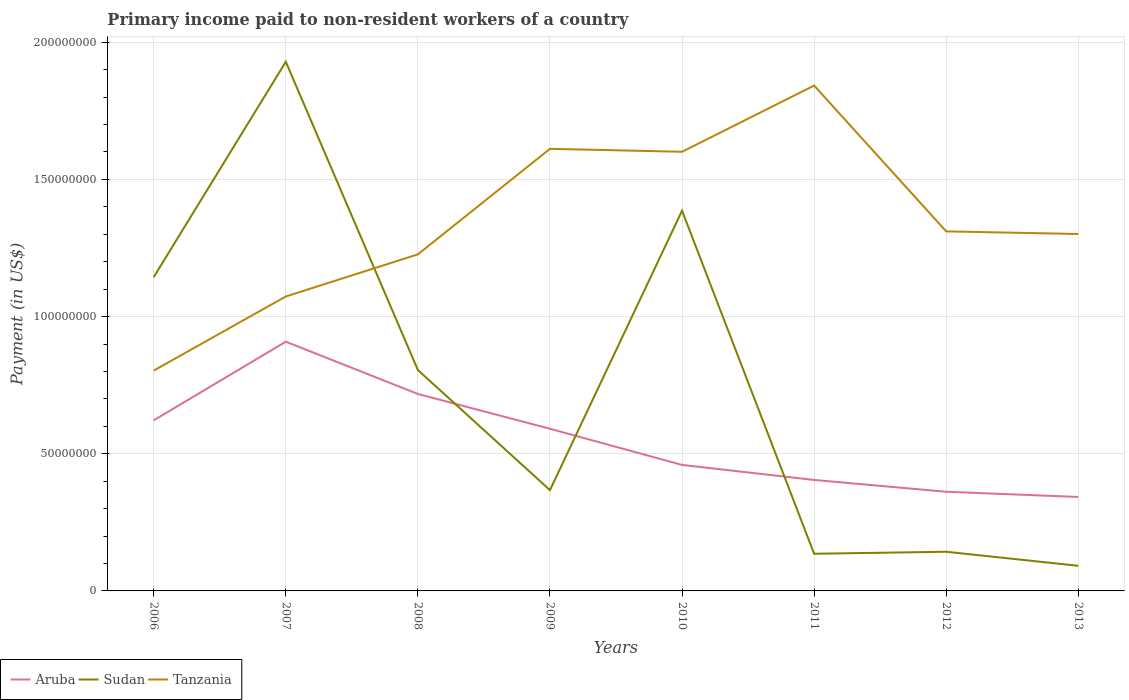How many different coloured lines are there?
Offer a terse response. 3. Is the number of lines equal to the number of legend labels?
Make the answer very short. Yes. Across all years, what is the maximum amount paid to workers in Sudan?
Your answer should be very brief. 9.16e+06. In which year was the amount paid to workers in Aruba maximum?
Ensure brevity in your answer.  2013. What is the total amount paid to workers in Aruba in the graph?
Your answer should be compact. 1.87e+07. What is the difference between the highest and the second highest amount paid to workers in Tanzania?
Provide a short and direct response. 1.04e+08. Does the graph contain any zero values?
Your response must be concise. No. Where does the legend appear in the graph?
Your answer should be compact. Bottom left. What is the title of the graph?
Your answer should be compact. Primary income paid to non-resident workers of a country. What is the label or title of the X-axis?
Make the answer very short. Years. What is the label or title of the Y-axis?
Provide a succinct answer. Payment (in US$). What is the Payment (in US$) in Aruba in 2006?
Provide a short and direct response. 6.22e+07. What is the Payment (in US$) of Sudan in 2006?
Provide a short and direct response. 1.14e+08. What is the Payment (in US$) in Tanzania in 2006?
Your answer should be very brief. 8.03e+07. What is the Payment (in US$) of Aruba in 2007?
Your response must be concise. 9.08e+07. What is the Payment (in US$) of Sudan in 2007?
Offer a very short reply. 1.93e+08. What is the Payment (in US$) of Tanzania in 2007?
Your answer should be compact. 1.07e+08. What is the Payment (in US$) in Aruba in 2008?
Ensure brevity in your answer.  7.18e+07. What is the Payment (in US$) of Sudan in 2008?
Your answer should be compact. 8.05e+07. What is the Payment (in US$) in Tanzania in 2008?
Make the answer very short. 1.23e+08. What is the Payment (in US$) in Aruba in 2009?
Give a very brief answer. 5.91e+07. What is the Payment (in US$) in Sudan in 2009?
Ensure brevity in your answer.  3.67e+07. What is the Payment (in US$) in Tanzania in 2009?
Your answer should be compact. 1.61e+08. What is the Payment (in US$) of Aruba in 2010?
Make the answer very short. 4.59e+07. What is the Payment (in US$) of Sudan in 2010?
Offer a terse response. 1.39e+08. What is the Payment (in US$) of Tanzania in 2010?
Make the answer very short. 1.60e+08. What is the Payment (in US$) of Aruba in 2011?
Provide a short and direct response. 4.04e+07. What is the Payment (in US$) of Sudan in 2011?
Make the answer very short. 1.35e+07. What is the Payment (in US$) of Tanzania in 2011?
Your answer should be compact. 1.84e+08. What is the Payment (in US$) in Aruba in 2012?
Offer a terse response. 3.61e+07. What is the Payment (in US$) of Sudan in 2012?
Your answer should be very brief. 1.43e+07. What is the Payment (in US$) in Tanzania in 2012?
Offer a terse response. 1.31e+08. What is the Payment (in US$) of Aruba in 2013?
Your answer should be compact. 3.42e+07. What is the Payment (in US$) in Sudan in 2013?
Your answer should be compact. 9.16e+06. What is the Payment (in US$) in Tanzania in 2013?
Ensure brevity in your answer.  1.30e+08. Across all years, what is the maximum Payment (in US$) in Aruba?
Provide a succinct answer. 9.08e+07. Across all years, what is the maximum Payment (in US$) of Sudan?
Provide a succinct answer. 1.93e+08. Across all years, what is the maximum Payment (in US$) in Tanzania?
Provide a succinct answer. 1.84e+08. Across all years, what is the minimum Payment (in US$) of Aruba?
Your answer should be very brief. 3.42e+07. Across all years, what is the minimum Payment (in US$) of Sudan?
Your answer should be very brief. 9.16e+06. Across all years, what is the minimum Payment (in US$) in Tanzania?
Your response must be concise. 8.03e+07. What is the total Payment (in US$) in Aruba in the graph?
Make the answer very short. 4.41e+08. What is the total Payment (in US$) of Sudan in the graph?
Offer a terse response. 6.00e+08. What is the total Payment (in US$) of Tanzania in the graph?
Offer a very short reply. 1.08e+09. What is the difference between the Payment (in US$) in Aruba in 2006 and that in 2007?
Keep it short and to the point. -2.87e+07. What is the difference between the Payment (in US$) in Sudan in 2006 and that in 2007?
Ensure brevity in your answer.  -7.85e+07. What is the difference between the Payment (in US$) in Tanzania in 2006 and that in 2007?
Offer a terse response. -2.70e+07. What is the difference between the Payment (in US$) of Aruba in 2006 and that in 2008?
Make the answer very short. -9.60e+06. What is the difference between the Payment (in US$) in Sudan in 2006 and that in 2008?
Your answer should be compact. 3.39e+07. What is the difference between the Payment (in US$) of Tanzania in 2006 and that in 2008?
Keep it short and to the point. -4.24e+07. What is the difference between the Payment (in US$) of Aruba in 2006 and that in 2009?
Provide a succinct answer. 3.08e+06. What is the difference between the Payment (in US$) in Sudan in 2006 and that in 2009?
Offer a very short reply. 7.76e+07. What is the difference between the Payment (in US$) in Tanzania in 2006 and that in 2009?
Provide a short and direct response. -8.08e+07. What is the difference between the Payment (in US$) in Aruba in 2006 and that in 2010?
Offer a very short reply. 1.63e+07. What is the difference between the Payment (in US$) of Sudan in 2006 and that in 2010?
Ensure brevity in your answer.  -2.42e+07. What is the difference between the Payment (in US$) of Tanzania in 2006 and that in 2010?
Ensure brevity in your answer.  -7.98e+07. What is the difference between the Payment (in US$) of Aruba in 2006 and that in 2011?
Offer a terse response. 2.17e+07. What is the difference between the Payment (in US$) in Sudan in 2006 and that in 2011?
Keep it short and to the point. 1.01e+08. What is the difference between the Payment (in US$) of Tanzania in 2006 and that in 2011?
Offer a very short reply. -1.04e+08. What is the difference between the Payment (in US$) in Aruba in 2006 and that in 2012?
Provide a succinct answer. 2.60e+07. What is the difference between the Payment (in US$) in Sudan in 2006 and that in 2012?
Ensure brevity in your answer.  1.00e+08. What is the difference between the Payment (in US$) of Tanzania in 2006 and that in 2012?
Offer a terse response. -5.07e+07. What is the difference between the Payment (in US$) of Aruba in 2006 and that in 2013?
Offer a very short reply. 2.79e+07. What is the difference between the Payment (in US$) in Sudan in 2006 and that in 2013?
Ensure brevity in your answer.  1.05e+08. What is the difference between the Payment (in US$) in Tanzania in 2006 and that in 2013?
Give a very brief answer. -4.98e+07. What is the difference between the Payment (in US$) of Aruba in 2007 and that in 2008?
Your answer should be compact. 1.91e+07. What is the difference between the Payment (in US$) in Sudan in 2007 and that in 2008?
Your answer should be very brief. 1.12e+08. What is the difference between the Payment (in US$) of Tanzania in 2007 and that in 2008?
Your response must be concise. -1.54e+07. What is the difference between the Payment (in US$) of Aruba in 2007 and that in 2009?
Offer a very short reply. 3.17e+07. What is the difference between the Payment (in US$) of Sudan in 2007 and that in 2009?
Give a very brief answer. 1.56e+08. What is the difference between the Payment (in US$) of Tanzania in 2007 and that in 2009?
Ensure brevity in your answer.  -5.38e+07. What is the difference between the Payment (in US$) in Aruba in 2007 and that in 2010?
Give a very brief answer. 4.49e+07. What is the difference between the Payment (in US$) in Sudan in 2007 and that in 2010?
Offer a very short reply. 5.43e+07. What is the difference between the Payment (in US$) of Tanzania in 2007 and that in 2010?
Offer a very short reply. -5.27e+07. What is the difference between the Payment (in US$) in Aruba in 2007 and that in 2011?
Keep it short and to the point. 5.04e+07. What is the difference between the Payment (in US$) in Sudan in 2007 and that in 2011?
Provide a succinct answer. 1.79e+08. What is the difference between the Payment (in US$) of Tanzania in 2007 and that in 2011?
Provide a short and direct response. -7.69e+07. What is the difference between the Payment (in US$) in Aruba in 2007 and that in 2012?
Give a very brief answer. 5.47e+07. What is the difference between the Payment (in US$) in Sudan in 2007 and that in 2012?
Give a very brief answer. 1.79e+08. What is the difference between the Payment (in US$) in Tanzania in 2007 and that in 2012?
Provide a succinct answer. -2.37e+07. What is the difference between the Payment (in US$) in Aruba in 2007 and that in 2013?
Your answer should be very brief. 5.66e+07. What is the difference between the Payment (in US$) in Sudan in 2007 and that in 2013?
Offer a terse response. 1.84e+08. What is the difference between the Payment (in US$) in Tanzania in 2007 and that in 2013?
Offer a very short reply. -2.28e+07. What is the difference between the Payment (in US$) in Aruba in 2008 and that in 2009?
Make the answer very short. 1.27e+07. What is the difference between the Payment (in US$) in Sudan in 2008 and that in 2009?
Offer a terse response. 4.38e+07. What is the difference between the Payment (in US$) in Tanzania in 2008 and that in 2009?
Your answer should be compact. -3.85e+07. What is the difference between the Payment (in US$) in Aruba in 2008 and that in 2010?
Give a very brief answer. 2.59e+07. What is the difference between the Payment (in US$) of Sudan in 2008 and that in 2010?
Give a very brief answer. -5.81e+07. What is the difference between the Payment (in US$) of Tanzania in 2008 and that in 2010?
Your answer should be compact. -3.74e+07. What is the difference between the Payment (in US$) of Aruba in 2008 and that in 2011?
Make the answer very short. 3.13e+07. What is the difference between the Payment (in US$) in Sudan in 2008 and that in 2011?
Offer a very short reply. 6.70e+07. What is the difference between the Payment (in US$) in Tanzania in 2008 and that in 2011?
Provide a succinct answer. -6.15e+07. What is the difference between the Payment (in US$) in Aruba in 2008 and that in 2012?
Keep it short and to the point. 3.56e+07. What is the difference between the Payment (in US$) of Sudan in 2008 and that in 2012?
Give a very brief answer. 6.62e+07. What is the difference between the Payment (in US$) of Tanzania in 2008 and that in 2012?
Your response must be concise. -8.38e+06. What is the difference between the Payment (in US$) in Aruba in 2008 and that in 2013?
Give a very brief answer. 3.75e+07. What is the difference between the Payment (in US$) of Sudan in 2008 and that in 2013?
Keep it short and to the point. 7.14e+07. What is the difference between the Payment (in US$) in Tanzania in 2008 and that in 2013?
Offer a terse response. -7.42e+06. What is the difference between the Payment (in US$) of Aruba in 2009 and that in 2010?
Offer a terse response. 1.32e+07. What is the difference between the Payment (in US$) in Sudan in 2009 and that in 2010?
Offer a terse response. -1.02e+08. What is the difference between the Payment (in US$) of Tanzania in 2009 and that in 2010?
Make the answer very short. 1.07e+06. What is the difference between the Payment (in US$) in Aruba in 2009 and that in 2011?
Make the answer very short. 1.87e+07. What is the difference between the Payment (in US$) of Sudan in 2009 and that in 2011?
Provide a succinct answer. 2.32e+07. What is the difference between the Payment (in US$) of Tanzania in 2009 and that in 2011?
Your answer should be compact. -2.31e+07. What is the difference between the Payment (in US$) of Aruba in 2009 and that in 2012?
Give a very brief answer. 2.30e+07. What is the difference between the Payment (in US$) in Sudan in 2009 and that in 2012?
Offer a terse response. 2.25e+07. What is the difference between the Payment (in US$) of Tanzania in 2009 and that in 2012?
Your answer should be compact. 3.01e+07. What is the difference between the Payment (in US$) of Aruba in 2009 and that in 2013?
Make the answer very short. 2.49e+07. What is the difference between the Payment (in US$) in Sudan in 2009 and that in 2013?
Your response must be concise. 2.76e+07. What is the difference between the Payment (in US$) in Tanzania in 2009 and that in 2013?
Keep it short and to the point. 3.10e+07. What is the difference between the Payment (in US$) of Aruba in 2010 and that in 2011?
Make the answer very short. 5.47e+06. What is the difference between the Payment (in US$) in Sudan in 2010 and that in 2011?
Your answer should be very brief. 1.25e+08. What is the difference between the Payment (in US$) in Tanzania in 2010 and that in 2011?
Ensure brevity in your answer.  -2.41e+07. What is the difference between the Payment (in US$) of Aruba in 2010 and that in 2012?
Give a very brief answer. 9.78e+06. What is the difference between the Payment (in US$) of Sudan in 2010 and that in 2012?
Make the answer very short. 1.24e+08. What is the difference between the Payment (in US$) in Tanzania in 2010 and that in 2012?
Your answer should be very brief. 2.90e+07. What is the difference between the Payment (in US$) in Aruba in 2010 and that in 2013?
Your answer should be compact. 1.17e+07. What is the difference between the Payment (in US$) in Sudan in 2010 and that in 2013?
Offer a terse response. 1.29e+08. What is the difference between the Payment (in US$) of Tanzania in 2010 and that in 2013?
Offer a very short reply. 3.00e+07. What is the difference between the Payment (in US$) in Aruba in 2011 and that in 2012?
Make the answer very short. 4.30e+06. What is the difference between the Payment (in US$) in Sudan in 2011 and that in 2012?
Your answer should be compact. -7.31e+05. What is the difference between the Payment (in US$) in Tanzania in 2011 and that in 2012?
Make the answer very short. 5.31e+07. What is the difference between the Payment (in US$) of Aruba in 2011 and that in 2013?
Your answer should be very brief. 6.20e+06. What is the difference between the Payment (in US$) of Sudan in 2011 and that in 2013?
Offer a terse response. 4.39e+06. What is the difference between the Payment (in US$) of Tanzania in 2011 and that in 2013?
Give a very brief answer. 5.41e+07. What is the difference between the Payment (in US$) in Aruba in 2012 and that in 2013?
Give a very brief answer. 1.90e+06. What is the difference between the Payment (in US$) in Sudan in 2012 and that in 2013?
Offer a terse response. 5.12e+06. What is the difference between the Payment (in US$) in Tanzania in 2012 and that in 2013?
Ensure brevity in your answer.  9.57e+05. What is the difference between the Payment (in US$) of Aruba in 2006 and the Payment (in US$) of Sudan in 2007?
Provide a short and direct response. -1.31e+08. What is the difference between the Payment (in US$) in Aruba in 2006 and the Payment (in US$) in Tanzania in 2007?
Make the answer very short. -4.51e+07. What is the difference between the Payment (in US$) in Sudan in 2006 and the Payment (in US$) in Tanzania in 2007?
Offer a terse response. 7.07e+06. What is the difference between the Payment (in US$) of Aruba in 2006 and the Payment (in US$) of Sudan in 2008?
Provide a short and direct response. -1.83e+07. What is the difference between the Payment (in US$) of Aruba in 2006 and the Payment (in US$) of Tanzania in 2008?
Offer a terse response. -6.05e+07. What is the difference between the Payment (in US$) of Sudan in 2006 and the Payment (in US$) of Tanzania in 2008?
Provide a short and direct response. -8.29e+06. What is the difference between the Payment (in US$) of Aruba in 2006 and the Payment (in US$) of Sudan in 2009?
Ensure brevity in your answer.  2.54e+07. What is the difference between the Payment (in US$) in Aruba in 2006 and the Payment (in US$) in Tanzania in 2009?
Provide a short and direct response. -9.90e+07. What is the difference between the Payment (in US$) of Sudan in 2006 and the Payment (in US$) of Tanzania in 2009?
Give a very brief answer. -4.68e+07. What is the difference between the Payment (in US$) of Aruba in 2006 and the Payment (in US$) of Sudan in 2010?
Ensure brevity in your answer.  -7.64e+07. What is the difference between the Payment (in US$) in Aruba in 2006 and the Payment (in US$) in Tanzania in 2010?
Your answer should be very brief. -9.79e+07. What is the difference between the Payment (in US$) in Sudan in 2006 and the Payment (in US$) in Tanzania in 2010?
Provide a short and direct response. -4.57e+07. What is the difference between the Payment (in US$) of Aruba in 2006 and the Payment (in US$) of Sudan in 2011?
Offer a very short reply. 4.86e+07. What is the difference between the Payment (in US$) of Aruba in 2006 and the Payment (in US$) of Tanzania in 2011?
Ensure brevity in your answer.  -1.22e+08. What is the difference between the Payment (in US$) of Sudan in 2006 and the Payment (in US$) of Tanzania in 2011?
Ensure brevity in your answer.  -6.98e+07. What is the difference between the Payment (in US$) in Aruba in 2006 and the Payment (in US$) in Sudan in 2012?
Ensure brevity in your answer.  4.79e+07. What is the difference between the Payment (in US$) of Aruba in 2006 and the Payment (in US$) of Tanzania in 2012?
Offer a terse response. -6.89e+07. What is the difference between the Payment (in US$) of Sudan in 2006 and the Payment (in US$) of Tanzania in 2012?
Offer a very short reply. -1.67e+07. What is the difference between the Payment (in US$) in Aruba in 2006 and the Payment (in US$) in Sudan in 2013?
Give a very brief answer. 5.30e+07. What is the difference between the Payment (in US$) of Aruba in 2006 and the Payment (in US$) of Tanzania in 2013?
Provide a short and direct response. -6.79e+07. What is the difference between the Payment (in US$) in Sudan in 2006 and the Payment (in US$) in Tanzania in 2013?
Give a very brief answer. -1.57e+07. What is the difference between the Payment (in US$) of Aruba in 2007 and the Payment (in US$) of Sudan in 2008?
Your answer should be compact. 1.03e+07. What is the difference between the Payment (in US$) in Aruba in 2007 and the Payment (in US$) in Tanzania in 2008?
Your response must be concise. -3.18e+07. What is the difference between the Payment (in US$) of Sudan in 2007 and the Payment (in US$) of Tanzania in 2008?
Your response must be concise. 7.02e+07. What is the difference between the Payment (in US$) in Aruba in 2007 and the Payment (in US$) in Sudan in 2009?
Provide a short and direct response. 5.41e+07. What is the difference between the Payment (in US$) in Aruba in 2007 and the Payment (in US$) in Tanzania in 2009?
Your answer should be very brief. -7.03e+07. What is the difference between the Payment (in US$) of Sudan in 2007 and the Payment (in US$) of Tanzania in 2009?
Provide a succinct answer. 3.17e+07. What is the difference between the Payment (in US$) in Aruba in 2007 and the Payment (in US$) in Sudan in 2010?
Offer a very short reply. -4.77e+07. What is the difference between the Payment (in US$) in Aruba in 2007 and the Payment (in US$) in Tanzania in 2010?
Offer a very short reply. -6.92e+07. What is the difference between the Payment (in US$) in Sudan in 2007 and the Payment (in US$) in Tanzania in 2010?
Ensure brevity in your answer.  3.28e+07. What is the difference between the Payment (in US$) in Aruba in 2007 and the Payment (in US$) in Sudan in 2011?
Provide a succinct answer. 7.73e+07. What is the difference between the Payment (in US$) of Aruba in 2007 and the Payment (in US$) of Tanzania in 2011?
Offer a very short reply. -9.34e+07. What is the difference between the Payment (in US$) of Sudan in 2007 and the Payment (in US$) of Tanzania in 2011?
Your answer should be compact. 8.67e+06. What is the difference between the Payment (in US$) in Aruba in 2007 and the Payment (in US$) in Sudan in 2012?
Keep it short and to the point. 7.66e+07. What is the difference between the Payment (in US$) of Aruba in 2007 and the Payment (in US$) of Tanzania in 2012?
Make the answer very short. -4.02e+07. What is the difference between the Payment (in US$) of Sudan in 2007 and the Payment (in US$) of Tanzania in 2012?
Your answer should be compact. 6.18e+07. What is the difference between the Payment (in US$) in Aruba in 2007 and the Payment (in US$) in Sudan in 2013?
Provide a succinct answer. 8.17e+07. What is the difference between the Payment (in US$) of Aruba in 2007 and the Payment (in US$) of Tanzania in 2013?
Your answer should be compact. -3.93e+07. What is the difference between the Payment (in US$) in Sudan in 2007 and the Payment (in US$) in Tanzania in 2013?
Keep it short and to the point. 6.28e+07. What is the difference between the Payment (in US$) of Aruba in 2008 and the Payment (in US$) of Sudan in 2009?
Make the answer very short. 3.50e+07. What is the difference between the Payment (in US$) in Aruba in 2008 and the Payment (in US$) in Tanzania in 2009?
Your answer should be compact. -8.93e+07. What is the difference between the Payment (in US$) of Sudan in 2008 and the Payment (in US$) of Tanzania in 2009?
Your answer should be compact. -8.06e+07. What is the difference between the Payment (in US$) of Aruba in 2008 and the Payment (in US$) of Sudan in 2010?
Make the answer very short. -6.68e+07. What is the difference between the Payment (in US$) of Aruba in 2008 and the Payment (in US$) of Tanzania in 2010?
Offer a very short reply. -8.83e+07. What is the difference between the Payment (in US$) in Sudan in 2008 and the Payment (in US$) in Tanzania in 2010?
Provide a short and direct response. -7.96e+07. What is the difference between the Payment (in US$) of Aruba in 2008 and the Payment (in US$) of Sudan in 2011?
Offer a very short reply. 5.82e+07. What is the difference between the Payment (in US$) of Aruba in 2008 and the Payment (in US$) of Tanzania in 2011?
Make the answer very short. -1.12e+08. What is the difference between the Payment (in US$) in Sudan in 2008 and the Payment (in US$) in Tanzania in 2011?
Provide a succinct answer. -1.04e+08. What is the difference between the Payment (in US$) of Aruba in 2008 and the Payment (in US$) of Sudan in 2012?
Offer a very short reply. 5.75e+07. What is the difference between the Payment (in US$) in Aruba in 2008 and the Payment (in US$) in Tanzania in 2012?
Give a very brief answer. -5.93e+07. What is the difference between the Payment (in US$) in Sudan in 2008 and the Payment (in US$) in Tanzania in 2012?
Your answer should be very brief. -5.05e+07. What is the difference between the Payment (in US$) in Aruba in 2008 and the Payment (in US$) in Sudan in 2013?
Your answer should be compact. 6.26e+07. What is the difference between the Payment (in US$) of Aruba in 2008 and the Payment (in US$) of Tanzania in 2013?
Offer a terse response. -5.83e+07. What is the difference between the Payment (in US$) of Sudan in 2008 and the Payment (in US$) of Tanzania in 2013?
Keep it short and to the point. -4.96e+07. What is the difference between the Payment (in US$) of Aruba in 2009 and the Payment (in US$) of Sudan in 2010?
Your response must be concise. -7.95e+07. What is the difference between the Payment (in US$) in Aruba in 2009 and the Payment (in US$) in Tanzania in 2010?
Your answer should be very brief. -1.01e+08. What is the difference between the Payment (in US$) in Sudan in 2009 and the Payment (in US$) in Tanzania in 2010?
Ensure brevity in your answer.  -1.23e+08. What is the difference between the Payment (in US$) in Aruba in 2009 and the Payment (in US$) in Sudan in 2011?
Make the answer very short. 4.56e+07. What is the difference between the Payment (in US$) in Aruba in 2009 and the Payment (in US$) in Tanzania in 2011?
Your answer should be compact. -1.25e+08. What is the difference between the Payment (in US$) in Sudan in 2009 and the Payment (in US$) in Tanzania in 2011?
Make the answer very short. -1.47e+08. What is the difference between the Payment (in US$) in Aruba in 2009 and the Payment (in US$) in Sudan in 2012?
Ensure brevity in your answer.  4.48e+07. What is the difference between the Payment (in US$) of Aruba in 2009 and the Payment (in US$) of Tanzania in 2012?
Keep it short and to the point. -7.19e+07. What is the difference between the Payment (in US$) in Sudan in 2009 and the Payment (in US$) in Tanzania in 2012?
Offer a very short reply. -9.43e+07. What is the difference between the Payment (in US$) of Aruba in 2009 and the Payment (in US$) of Sudan in 2013?
Provide a succinct answer. 4.99e+07. What is the difference between the Payment (in US$) of Aruba in 2009 and the Payment (in US$) of Tanzania in 2013?
Provide a succinct answer. -7.10e+07. What is the difference between the Payment (in US$) in Sudan in 2009 and the Payment (in US$) in Tanzania in 2013?
Ensure brevity in your answer.  -9.34e+07. What is the difference between the Payment (in US$) in Aruba in 2010 and the Payment (in US$) in Sudan in 2011?
Ensure brevity in your answer.  3.24e+07. What is the difference between the Payment (in US$) in Aruba in 2010 and the Payment (in US$) in Tanzania in 2011?
Your answer should be very brief. -1.38e+08. What is the difference between the Payment (in US$) of Sudan in 2010 and the Payment (in US$) of Tanzania in 2011?
Your answer should be compact. -4.56e+07. What is the difference between the Payment (in US$) of Aruba in 2010 and the Payment (in US$) of Sudan in 2012?
Offer a very short reply. 3.16e+07. What is the difference between the Payment (in US$) in Aruba in 2010 and the Payment (in US$) in Tanzania in 2012?
Provide a succinct answer. -8.51e+07. What is the difference between the Payment (in US$) in Sudan in 2010 and the Payment (in US$) in Tanzania in 2012?
Ensure brevity in your answer.  7.53e+06. What is the difference between the Payment (in US$) in Aruba in 2010 and the Payment (in US$) in Sudan in 2013?
Make the answer very short. 3.68e+07. What is the difference between the Payment (in US$) in Aruba in 2010 and the Payment (in US$) in Tanzania in 2013?
Provide a short and direct response. -8.42e+07. What is the difference between the Payment (in US$) of Sudan in 2010 and the Payment (in US$) of Tanzania in 2013?
Ensure brevity in your answer.  8.48e+06. What is the difference between the Payment (in US$) of Aruba in 2011 and the Payment (in US$) of Sudan in 2012?
Provide a succinct answer. 2.62e+07. What is the difference between the Payment (in US$) of Aruba in 2011 and the Payment (in US$) of Tanzania in 2012?
Provide a succinct answer. -9.06e+07. What is the difference between the Payment (in US$) of Sudan in 2011 and the Payment (in US$) of Tanzania in 2012?
Keep it short and to the point. -1.18e+08. What is the difference between the Payment (in US$) in Aruba in 2011 and the Payment (in US$) in Sudan in 2013?
Give a very brief answer. 3.13e+07. What is the difference between the Payment (in US$) in Aruba in 2011 and the Payment (in US$) in Tanzania in 2013?
Offer a very short reply. -8.96e+07. What is the difference between the Payment (in US$) in Sudan in 2011 and the Payment (in US$) in Tanzania in 2013?
Provide a succinct answer. -1.17e+08. What is the difference between the Payment (in US$) of Aruba in 2012 and the Payment (in US$) of Sudan in 2013?
Keep it short and to the point. 2.70e+07. What is the difference between the Payment (in US$) in Aruba in 2012 and the Payment (in US$) in Tanzania in 2013?
Keep it short and to the point. -9.40e+07. What is the difference between the Payment (in US$) in Sudan in 2012 and the Payment (in US$) in Tanzania in 2013?
Provide a short and direct response. -1.16e+08. What is the average Payment (in US$) in Aruba per year?
Your response must be concise. 5.51e+07. What is the average Payment (in US$) of Sudan per year?
Provide a short and direct response. 7.50e+07. What is the average Payment (in US$) in Tanzania per year?
Provide a short and direct response. 1.35e+08. In the year 2006, what is the difference between the Payment (in US$) of Aruba and Payment (in US$) of Sudan?
Ensure brevity in your answer.  -5.22e+07. In the year 2006, what is the difference between the Payment (in US$) in Aruba and Payment (in US$) in Tanzania?
Your answer should be compact. -1.81e+07. In the year 2006, what is the difference between the Payment (in US$) of Sudan and Payment (in US$) of Tanzania?
Provide a succinct answer. 3.41e+07. In the year 2007, what is the difference between the Payment (in US$) of Aruba and Payment (in US$) of Sudan?
Your answer should be compact. -1.02e+08. In the year 2007, what is the difference between the Payment (in US$) in Aruba and Payment (in US$) in Tanzania?
Make the answer very short. -1.65e+07. In the year 2007, what is the difference between the Payment (in US$) of Sudan and Payment (in US$) of Tanzania?
Keep it short and to the point. 8.55e+07. In the year 2008, what is the difference between the Payment (in US$) in Aruba and Payment (in US$) in Sudan?
Provide a short and direct response. -8.72e+06. In the year 2008, what is the difference between the Payment (in US$) in Aruba and Payment (in US$) in Tanzania?
Ensure brevity in your answer.  -5.09e+07. In the year 2008, what is the difference between the Payment (in US$) of Sudan and Payment (in US$) of Tanzania?
Provide a succinct answer. -4.22e+07. In the year 2009, what is the difference between the Payment (in US$) in Aruba and Payment (in US$) in Sudan?
Provide a short and direct response. 2.24e+07. In the year 2009, what is the difference between the Payment (in US$) of Aruba and Payment (in US$) of Tanzania?
Keep it short and to the point. -1.02e+08. In the year 2009, what is the difference between the Payment (in US$) in Sudan and Payment (in US$) in Tanzania?
Your answer should be compact. -1.24e+08. In the year 2010, what is the difference between the Payment (in US$) in Aruba and Payment (in US$) in Sudan?
Offer a terse response. -9.27e+07. In the year 2010, what is the difference between the Payment (in US$) of Aruba and Payment (in US$) of Tanzania?
Ensure brevity in your answer.  -1.14e+08. In the year 2010, what is the difference between the Payment (in US$) of Sudan and Payment (in US$) of Tanzania?
Your answer should be compact. -2.15e+07. In the year 2011, what is the difference between the Payment (in US$) of Aruba and Payment (in US$) of Sudan?
Keep it short and to the point. 2.69e+07. In the year 2011, what is the difference between the Payment (in US$) in Aruba and Payment (in US$) in Tanzania?
Give a very brief answer. -1.44e+08. In the year 2011, what is the difference between the Payment (in US$) in Sudan and Payment (in US$) in Tanzania?
Your answer should be compact. -1.71e+08. In the year 2012, what is the difference between the Payment (in US$) in Aruba and Payment (in US$) in Sudan?
Offer a terse response. 2.19e+07. In the year 2012, what is the difference between the Payment (in US$) in Aruba and Payment (in US$) in Tanzania?
Make the answer very short. -9.49e+07. In the year 2012, what is the difference between the Payment (in US$) in Sudan and Payment (in US$) in Tanzania?
Provide a succinct answer. -1.17e+08. In the year 2013, what is the difference between the Payment (in US$) of Aruba and Payment (in US$) of Sudan?
Make the answer very short. 2.51e+07. In the year 2013, what is the difference between the Payment (in US$) in Aruba and Payment (in US$) in Tanzania?
Your response must be concise. -9.59e+07. In the year 2013, what is the difference between the Payment (in US$) in Sudan and Payment (in US$) in Tanzania?
Keep it short and to the point. -1.21e+08. What is the ratio of the Payment (in US$) in Aruba in 2006 to that in 2007?
Your response must be concise. 0.68. What is the ratio of the Payment (in US$) of Sudan in 2006 to that in 2007?
Ensure brevity in your answer.  0.59. What is the ratio of the Payment (in US$) of Tanzania in 2006 to that in 2007?
Your answer should be compact. 0.75. What is the ratio of the Payment (in US$) in Aruba in 2006 to that in 2008?
Ensure brevity in your answer.  0.87. What is the ratio of the Payment (in US$) of Sudan in 2006 to that in 2008?
Provide a short and direct response. 1.42. What is the ratio of the Payment (in US$) in Tanzania in 2006 to that in 2008?
Make the answer very short. 0.65. What is the ratio of the Payment (in US$) of Aruba in 2006 to that in 2009?
Offer a very short reply. 1.05. What is the ratio of the Payment (in US$) in Sudan in 2006 to that in 2009?
Your response must be concise. 3.11. What is the ratio of the Payment (in US$) of Tanzania in 2006 to that in 2009?
Give a very brief answer. 0.5. What is the ratio of the Payment (in US$) in Aruba in 2006 to that in 2010?
Give a very brief answer. 1.35. What is the ratio of the Payment (in US$) of Sudan in 2006 to that in 2010?
Provide a short and direct response. 0.83. What is the ratio of the Payment (in US$) in Tanzania in 2006 to that in 2010?
Ensure brevity in your answer.  0.5. What is the ratio of the Payment (in US$) in Aruba in 2006 to that in 2011?
Your answer should be very brief. 1.54. What is the ratio of the Payment (in US$) in Sudan in 2006 to that in 2011?
Ensure brevity in your answer.  8.44. What is the ratio of the Payment (in US$) in Tanzania in 2006 to that in 2011?
Offer a terse response. 0.44. What is the ratio of the Payment (in US$) in Aruba in 2006 to that in 2012?
Provide a short and direct response. 1.72. What is the ratio of the Payment (in US$) of Sudan in 2006 to that in 2012?
Provide a succinct answer. 8.01. What is the ratio of the Payment (in US$) in Tanzania in 2006 to that in 2012?
Offer a very short reply. 0.61. What is the ratio of the Payment (in US$) in Aruba in 2006 to that in 2013?
Offer a very short reply. 1.82. What is the ratio of the Payment (in US$) in Sudan in 2006 to that in 2013?
Offer a very short reply. 12.49. What is the ratio of the Payment (in US$) in Tanzania in 2006 to that in 2013?
Give a very brief answer. 0.62. What is the ratio of the Payment (in US$) in Aruba in 2007 to that in 2008?
Offer a very short reply. 1.27. What is the ratio of the Payment (in US$) in Sudan in 2007 to that in 2008?
Your response must be concise. 2.4. What is the ratio of the Payment (in US$) of Tanzania in 2007 to that in 2008?
Provide a short and direct response. 0.87. What is the ratio of the Payment (in US$) of Aruba in 2007 to that in 2009?
Your answer should be very brief. 1.54. What is the ratio of the Payment (in US$) of Sudan in 2007 to that in 2009?
Provide a short and direct response. 5.25. What is the ratio of the Payment (in US$) of Tanzania in 2007 to that in 2009?
Your answer should be very brief. 0.67. What is the ratio of the Payment (in US$) of Aruba in 2007 to that in 2010?
Your answer should be compact. 1.98. What is the ratio of the Payment (in US$) of Sudan in 2007 to that in 2010?
Offer a terse response. 1.39. What is the ratio of the Payment (in US$) of Tanzania in 2007 to that in 2010?
Offer a very short reply. 0.67. What is the ratio of the Payment (in US$) of Aruba in 2007 to that in 2011?
Provide a succinct answer. 2.25. What is the ratio of the Payment (in US$) in Sudan in 2007 to that in 2011?
Your answer should be compact. 14.24. What is the ratio of the Payment (in US$) of Tanzania in 2007 to that in 2011?
Offer a terse response. 0.58. What is the ratio of the Payment (in US$) in Aruba in 2007 to that in 2012?
Offer a terse response. 2.51. What is the ratio of the Payment (in US$) of Sudan in 2007 to that in 2012?
Provide a short and direct response. 13.51. What is the ratio of the Payment (in US$) of Tanzania in 2007 to that in 2012?
Give a very brief answer. 0.82. What is the ratio of the Payment (in US$) in Aruba in 2007 to that in 2013?
Provide a succinct answer. 2.65. What is the ratio of the Payment (in US$) in Sudan in 2007 to that in 2013?
Offer a very short reply. 21.06. What is the ratio of the Payment (in US$) of Tanzania in 2007 to that in 2013?
Offer a terse response. 0.82. What is the ratio of the Payment (in US$) in Aruba in 2008 to that in 2009?
Keep it short and to the point. 1.21. What is the ratio of the Payment (in US$) of Sudan in 2008 to that in 2009?
Make the answer very short. 2.19. What is the ratio of the Payment (in US$) in Tanzania in 2008 to that in 2009?
Provide a succinct answer. 0.76. What is the ratio of the Payment (in US$) in Aruba in 2008 to that in 2010?
Provide a succinct answer. 1.56. What is the ratio of the Payment (in US$) in Sudan in 2008 to that in 2010?
Your answer should be very brief. 0.58. What is the ratio of the Payment (in US$) in Tanzania in 2008 to that in 2010?
Give a very brief answer. 0.77. What is the ratio of the Payment (in US$) in Aruba in 2008 to that in 2011?
Provide a succinct answer. 1.77. What is the ratio of the Payment (in US$) of Sudan in 2008 to that in 2011?
Provide a short and direct response. 5.94. What is the ratio of the Payment (in US$) of Tanzania in 2008 to that in 2011?
Offer a terse response. 0.67. What is the ratio of the Payment (in US$) of Aruba in 2008 to that in 2012?
Offer a very short reply. 1.99. What is the ratio of the Payment (in US$) in Sudan in 2008 to that in 2012?
Provide a succinct answer. 5.64. What is the ratio of the Payment (in US$) of Tanzania in 2008 to that in 2012?
Keep it short and to the point. 0.94. What is the ratio of the Payment (in US$) in Aruba in 2008 to that in 2013?
Ensure brevity in your answer.  2.1. What is the ratio of the Payment (in US$) in Sudan in 2008 to that in 2013?
Give a very brief answer. 8.79. What is the ratio of the Payment (in US$) of Tanzania in 2008 to that in 2013?
Ensure brevity in your answer.  0.94. What is the ratio of the Payment (in US$) of Aruba in 2009 to that in 2010?
Offer a very short reply. 1.29. What is the ratio of the Payment (in US$) of Sudan in 2009 to that in 2010?
Keep it short and to the point. 0.27. What is the ratio of the Payment (in US$) of Tanzania in 2009 to that in 2010?
Your answer should be compact. 1.01. What is the ratio of the Payment (in US$) in Aruba in 2009 to that in 2011?
Make the answer very short. 1.46. What is the ratio of the Payment (in US$) of Sudan in 2009 to that in 2011?
Your answer should be compact. 2.71. What is the ratio of the Payment (in US$) of Tanzania in 2009 to that in 2011?
Ensure brevity in your answer.  0.87. What is the ratio of the Payment (in US$) of Aruba in 2009 to that in 2012?
Make the answer very short. 1.64. What is the ratio of the Payment (in US$) in Sudan in 2009 to that in 2012?
Keep it short and to the point. 2.57. What is the ratio of the Payment (in US$) of Tanzania in 2009 to that in 2012?
Keep it short and to the point. 1.23. What is the ratio of the Payment (in US$) in Aruba in 2009 to that in 2013?
Your answer should be very brief. 1.73. What is the ratio of the Payment (in US$) in Sudan in 2009 to that in 2013?
Provide a short and direct response. 4.01. What is the ratio of the Payment (in US$) in Tanzania in 2009 to that in 2013?
Give a very brief answer. 1.24. What is the ratio of the Payment (in US$) of Aruba in 2010 to that in 2011?
Offer a very short reply. 1.14. What is the ratio of the Payment (in US$) in Sudan in 2010 to that in 2011?
Your answer should be compact. 10.23. What is the ratio of the Payment (in US$) of Tanzania in 2010 to that in 2011?
Offer a terse response. 0.87. What is the ratio of the Payment (in US$) in Aruba in 2010 to that in 2012?
Your response must be concise. 1.27. What is the ratio of the Payment (in US$) of Sudan in 2010 to that in 2012?
Your response must be concise. 9.71. What is the ratio of the Payment (in US$) of Tanzania in 2010 to that in 2012?
Provide a succinct answer. 1.22. What is the ratio of the Payment (in US$) of Aruba in 2010 to that in 2013?
Offer a terse response. 1.34. What is the ratio of the Payment (in US$) in Sudan in 2010 to that in 2013?
Provide a short and direct response. 15.13. What is the ratio of the Payment (in US$) in Tanzania in 2010 to that in 2013?
Provide a short and direct response. 1.23. What is the ratio of the Payment (in US$) of Aruba in 2011 to that in 2012?
Your answer should be very brief. 1.12. What is the ratio of the Payment (in US$) in Sudan in 2011 to that in 2012?
Your answer should be very brief. 0.95. What is the ratio of the Payment (in US$) in Tanzania in 2011 to that in 2012?
Give a very brief answer. 1.41. What is the ratio of the Payment (in US$) in Aruba in 2011 to that in 2013?
Your answer should be very brief. 1.18. What is the ratio of the Payment (in US$) in Sudan in 2011 to that in 2013?
Give a very brief answer. 1.48. What is the ratio of the Payment (in US$) in Tanzania in 2011 to that in 2013?
Give a very brief answer. 1.42. What is the ratio of the Payment (in US$) in Aruba in 2012 to that in 2013?
Your answer should be very brief. 1.06. What is the ratio of the Payment (in US$) of Sudan in 2012 to that in 2013?
Make the answer very short. 1.56. What is the ratio of the Payment (in US$) in Tanzania in 2012 to that in 2013?
Provide a succinct answer. 1.01. What is the difference between the highest and the second highest Payment (in US$) in Aruba?
Ensure brevity in your answer.  1.91e+07. What is the difference between the highest and the second highest Payment (in US$) of Sudan?
Provide a succinct answer. 5.43e+07. What is the difference between the highest and the second highest Payment (in US$) of Tanzania?
Provide a succinct answer. 2.31e+07. What is the difference between the highest and the lowest Payment (in US$) in Aruba?
Provide a short and direct response. 5.66e+07. What is the difference between the highest and the lowest Payment (in US$) of Sudan?
Your response must be concise. 1.84e+08. What is the difference between the highest and the lowest Payment (in US$) in Tanzania?
Your answer should be very brief. 1.04e+08. 